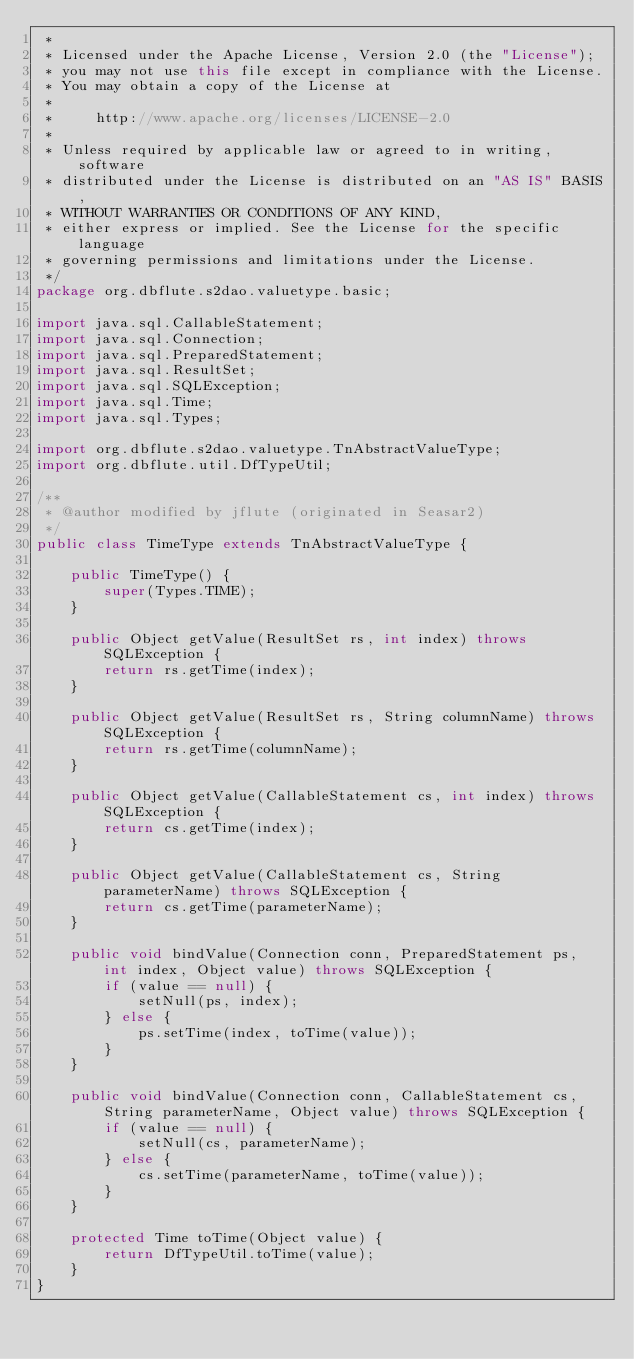Convert code to text. <code><loc_0><loc_0><loc_500><loc_500><_Java_> *
 * Licensed under the Apache License, Version 2.0 (the "License");
 * you may not use this file except in compliance with the License.
 * You may obtain a copy of the License at
 *
 *     http://www.apache.org/licenses/LICENSE-2.0
 *
 * Unless required by applicable law or agreed to in writing, software
 * distributed under the License is distributed on an "AS IS" BASIS,
 * WITHOUT WARRANTIES OR CONDITIONS OF ANY KIND,
 * either express or implied. See the License for the specific language
 * governing permissions and limitations under the License.
 */
package org.dbflute.s2dao.valuetype.basic;

import java.sql.CallableStatement;
import java.sql.Connection;
import java.sql.PreparedStatement;
import java.sql.ResultSet;
import java.sql.SQLException;
import java.sql.Time;
import java.sql.Types;

import org.dbflute.s2dao.valuetype.TnAbstractValueType;
import org.dbflute.util.DfTypeUtil;

/**
 * @author modified by jflute (originated in Seasar2)
 */
public class TimeType extends TnAbstractValueType {

    public TimeType() {
        super(Types.TIME);
    }

    public Object getValue(ResultSet rs, int index) throws SQLException {
        return rs.getTime(index);
    }

    public Object getValue(ResultSet rs, String columnName) throws SQLException {
        return rs.getTime(columnName);
    }

    public Object getValue(CallableStatement cs, int index) throws SQLException {
        return cs.getTime(index);
    }

    public Object getValue(CallableStatement cs, String parameterName) throws SQLException {
        return cs.getTime(parameterName);
    }

    public void bindValue(Connection conn, PreparedStatement ps, int index, Object value) throws SQLException {
        if (value == null) {
            setNull(ps, index);
        } else {
            ps.setTime(index, toTime(value));
        }
    }

    public void bindValue(Connection conn, CallableStatement cs, String parameterName, Object value) throws SQLException {
        if (value == null) {
            setNull(cs, parameterName);
        } else {
            cs.setTime(parameterName, toTime(value));
        }
    }

    protected Time toTime(Object value) {
        return DfTypeUtil.toTime(value);
    }
}</code> 